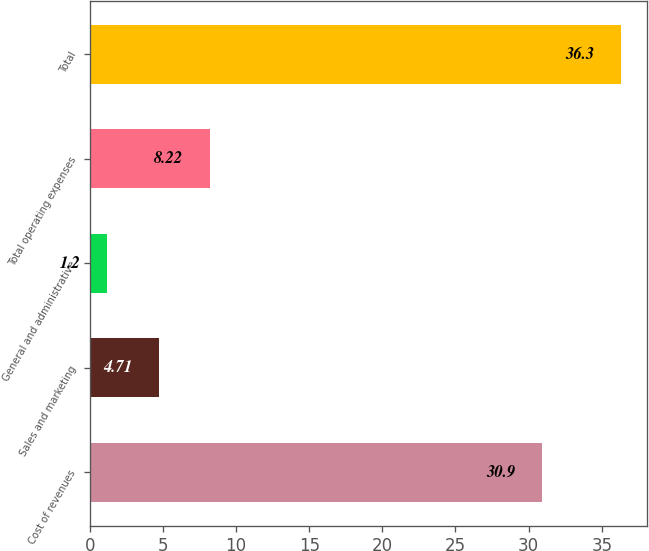Convert chart. <chart><loc_0><loc_0><loc_500><loc_500><bar_chart><fcel>Cost of revenues<fcel>Sales and marketing<fcel>General and administrative<fcel>Total operating expenses<fcel>Total<nl><fcel>30.9<fcel>4.71<fcel>1.2<fcel>8.22<fcel>36.3<nl></chart> 